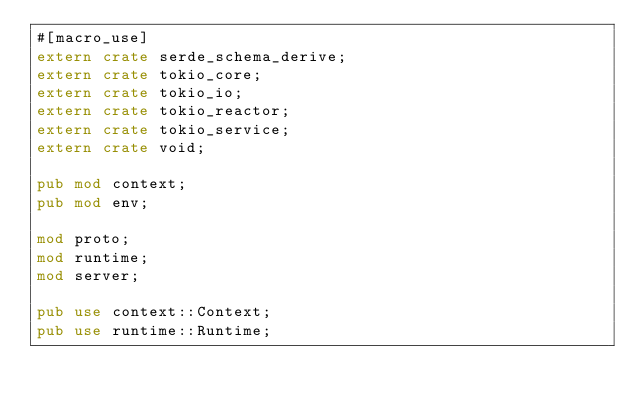<code> <loc_0><loc_0><loc_500><loc_500><_Rust_>#[macro_use]
extern crate serde_schema_derive;
extern crate tokio_core;
extern crate tokio_io;
extern crate tokio_reactor;
extern crate tokio_service;
extern crate void;

pub mod context;
pub mod env;

mod proto;
mod runtime;
mod server;

pub use context::Context;
pub use runtime::Runtime;
</code> 